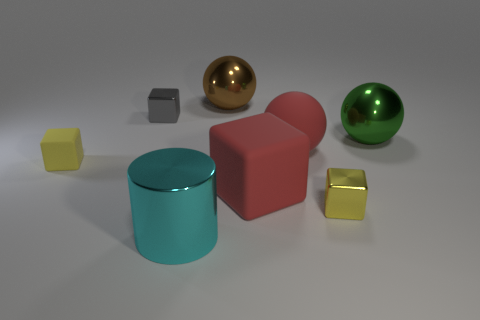Subtract 1 cubes. How many cubes are left? 3 Add 1 large cyan things. How many objects exist? 9 Subtract all balls. How many objects are left? 5 Add 8 small metallic things. How many small metallic things exist? 10 Subtract 0 yellow cylinders. How many objects are left? 8 Subtract all large cyan metal objects. Subtract all blue shiny cubes. How many objects are left? 7 Add 5 small yellow cubes. How many small yellow cubes are left? 7 